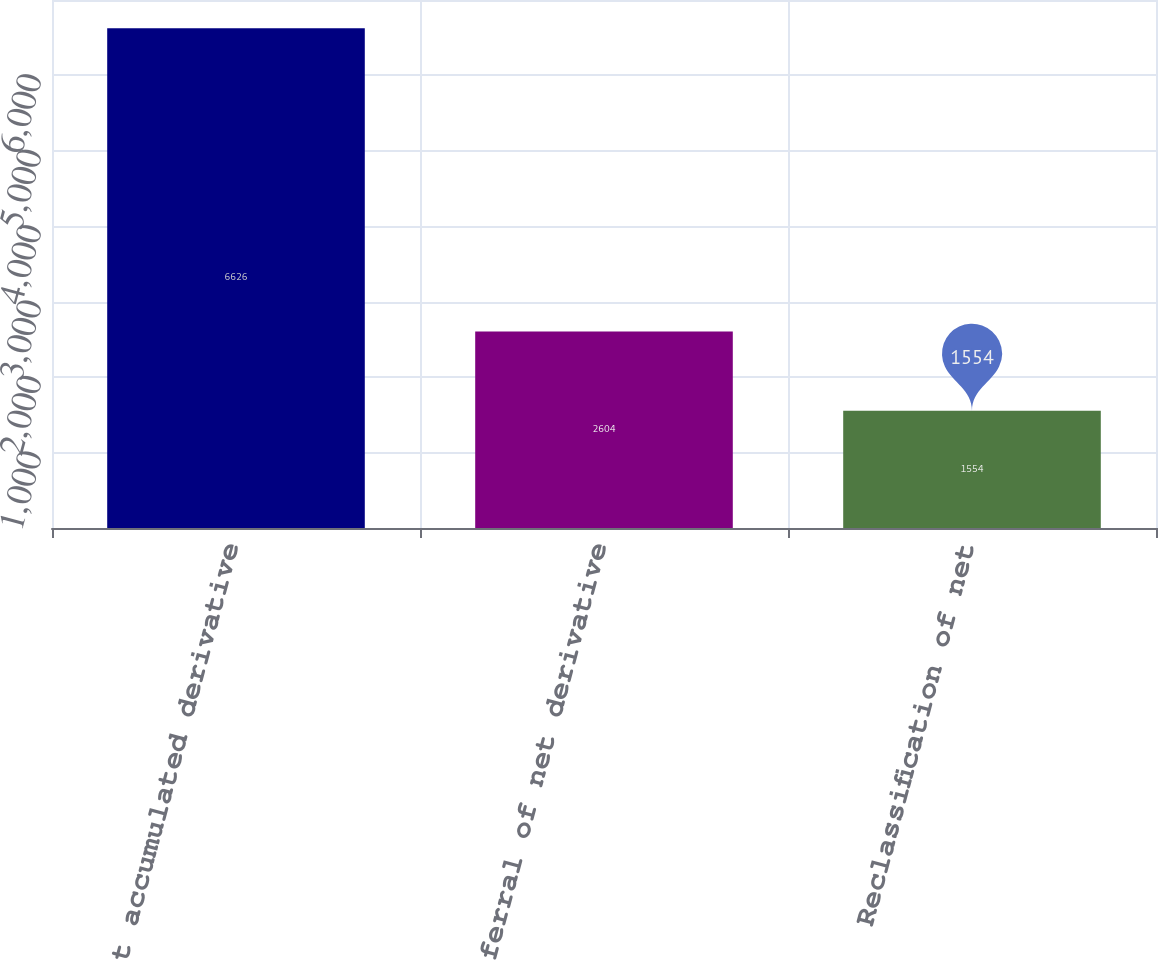<chart> <loc_0><loc_0><loc_500><loc_500><bar_chart><fcel>Net accumulated derivative<fcel>Deferral of net derivative<fcel>Reclassification of net<nl><fcel>6626<fcel>2604<fcel>1554<nl></chart> 